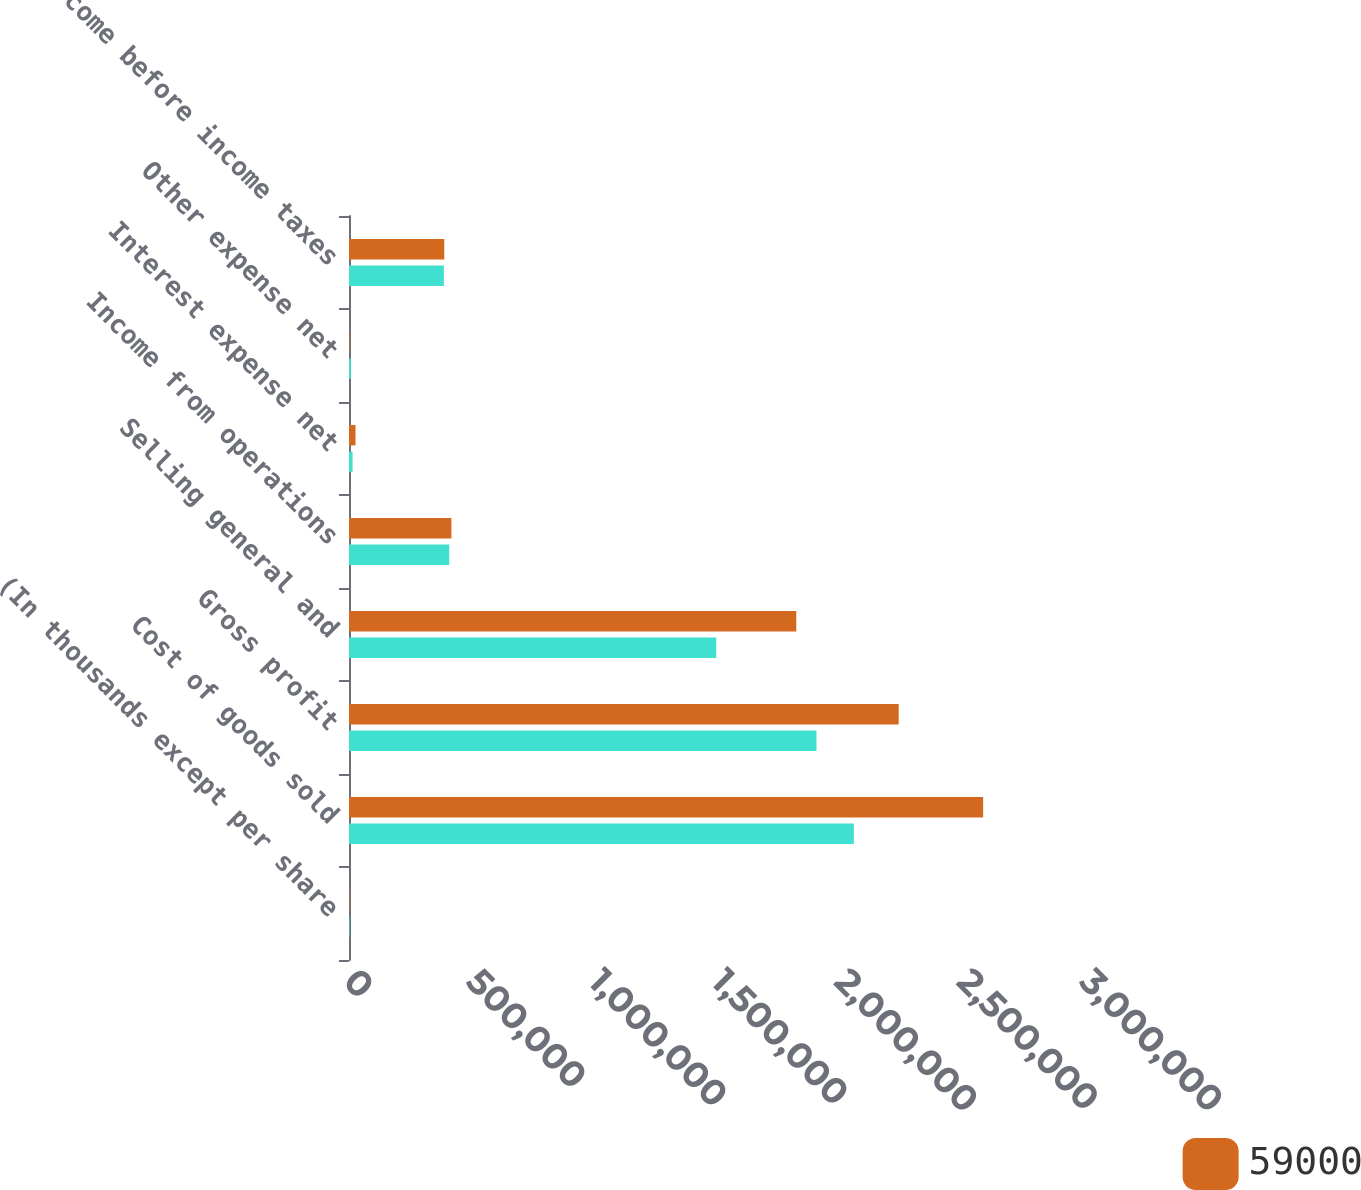Convert chart. <chart><loc_0><loc_0><loc_500><loc_500><stacked_bar_chart><ecel><fcel>(In thousands except per share<fcel>Cost of goods sold<fcel>Gross profit<fcel>Selling general and<fcel>Income from operations<fcel>Interest expense net<fcel>Other expense net<fcel>Income before income taxes<nl><fcel>59000<fcel>2016<fcel>2.58472e+06<fcel>2.24061e+06<fcel>1.82314e+06<fcel>417471<fcel>26434<fcel>2755<fcel>388282<nl><fcel>nan<fcel>2015<fcel>2.05777e+06<fcel>1.90555e+06<fcel>1.497e+06<fcel>408547<fcel>14628<fcel>7234<fcel>386685<nl></chart> 